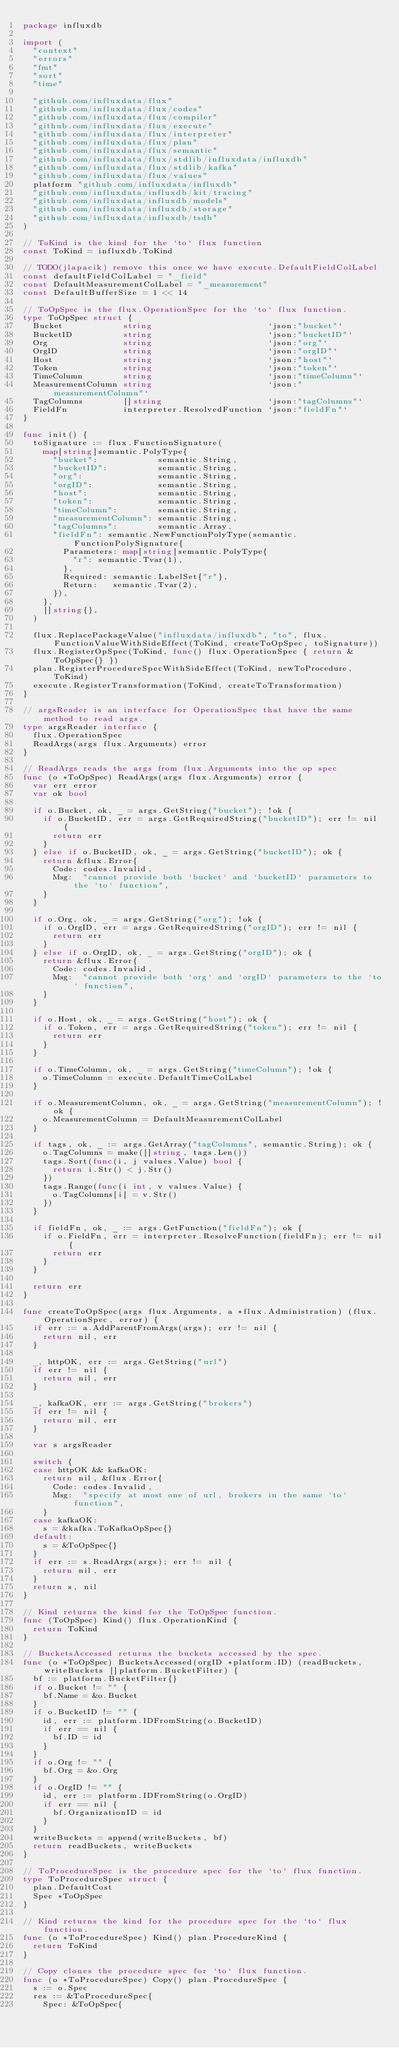<code> <loc_0><loc_0><loc_500><loc_500><_Go_>package influxdb

import (
	"context"
	"errors"
	"fmt"
	"sort"
	"time"

	"github.com/influxdata/flux"
	"github.com/influxdata/flux/codes"
	"github.com/influxdata/flux/compiler"
	"github.com/influxdata/flux/execute"
	"github.com/influxdata/flux/interpreter"
	"github.com/influxdata/flux/plan"
	"github.com/influxdata/flux/semantic"
	"github.com/influxdata/flux/stdlib/influxdata/influxdb"
	"github.com/influxdata/flux/stdlib/kafka"
	"github.com/influxdata/flux/values"
	platform "github.com/influxdata/influxdb"
	"github.com/influxdata/influxdb/kit/tracing"
	"github.com/influxdata/influxdb/models"
	"github.com/influxdata/influxdb/storage"
	"github.com/influxdata/influxdb/tsdb"
)

// ToKind is the kind for the `to` flux function
const ToKind = influxdb.ToKind

// TODO(jlapacik) remove this once we have execute.DefaultFieldColLabel
const defaultFieldColLabel = "_field"
const DefaultMeasurementColLabel = "_measurement"
const DefaultBufferSize = 1 << 14

// ToOpSpec is the flux.OperationSpec for the `to` flux function.
type ToOpSpec struct {
	Bucket            string                       `json:"bucket"`
	BucketID          string                       `json:"bucketID"`
	Org               string                       `json:"org"`
	OrgID             string                       `json:"orgID"`
	Host              string                       `json:"host"`
	Token             string                       `json:"token"`
	TimeColumn        string                       `json:"timeColumn"`
	MeasurementColumn string                       `json:"measurementColumn"`
	TagColumns        []string                     `json:"tagColumns"`
	FieldFn           interpreter.ResolvedFunction `json:"fieldFn"`
}

func init() {
	toSignature := flux.FunctionSignature(
		map[string]semantic.PolyType{
			"bucket":            semantic.String,
			"bucketID":          semantic.String,
			"org":               semantic.String,
			"orgID":             semantic.String,
			"host":              semantic.String,
			"token":             semantic.String,
			"timeColumn":        semantic.String,
			"measurementColumn": semantic.String,
			"tagColumns":        semantic.Array,
			"fieldFn": semantic.NewFunctionPolyType(semantic.FunctionPolySignature{
				Parameters: map[string]semantic.PolyType{
					"r": semantic.Tvar(1),
				},
				Required: semantic.LabelSet{"r"},
				Return:   semantic.Tvar(2),
			}),
		},
		[]string{},
	)

	flux.ReplacePackageValue("influxdata/influxdb", "to", flux.FunctionValueWithSideEffect(ToKind, createToOpSpec, toSignature))
	flux.RegisterOpSpec(ToKind, func() flux.OperationSpec { return &ToOpSpec{} })
	plan.RegisterProcedureSpecWithSideEffect(ToKind, newToProcedure, ToKind)
	execute.RegisterTransformation(ToKind, createToTransformation)
}

// argsReader is an interface for OperationSpec that have the same method to read args.
type argsReader interface {
	flux.OperationSpec
	ReadArgs(args flux.Arguments) error
}

// ReadArgs reads the args from flux.Arguments into the op spec
func (o *ToOpSpec) ReadArgs(args flux.Arguments) error {
	var err error
	var ok bool

	if o.Bucket, ok, _ = args.GetString("bucket"); !ok {
		if o.BucketID, err = args.GetRequiredString("bucketID"); err != nil {
			return err
		}
	} else if o.BucketID, ok, _ = args.GetString("bucketID"); ok {
		return &flux.Error{
			Code: codes.Invalid,
			Msg:  "cannot provide both `bucket` and `bucketID` parameters to the `to` function",
		}
	}

	if o.Org, ok, _ = args.GetString("org"); !ok {
		if o.OrgID, err = args.GetRequiredString("orgID"); err != nil {
			return err
		}
	} else if o.OrgID, ok, _ = args.GetString("orgID"); ok {
		return &flux.Error{
			Code: codes.Invalid,
			Msg:  "cannot provide both `org` and `orgID` parameters to the `to` function",
		}
	}

	if o.Host, ok, _ = args.GetString("host"); ok {
		if o.Token, err = args.GetRequiredString("token"); err != nil {
			return err
		}
	}

	if o.TimeColumn, ok, _ = args.GetString("timeColumn"); !ok {
		o.TimeColumn = execute.DefaultTimeColLabel
	}

	if o.MeasurementColumn, ok, _ = args.GetString("measurementColumn"); !ok {
		o.MeasurementColumn = DefaultMeasurementColLabel
	}

	if tags, ok, _ := args.GetArray("tagColumns", semantic.String); ok {
		o.TagColumns = make([]string, tags.Len())
		tags.Sort(func(i, j values.Value) bool {
			return i.Str() < j.Str()
		})
		tags.Range(func(i int, v values.Value) {
			o.TagColumns[i] = v.Str()
		})
	}

	if fieldFn, ok, _ := args.GetFunction("fieldFn"); ok {
		if o.FieldFn, err = interpreter.ResolveFunction(fieldFn); err != nil {
			return err
		}
	}

	return err
}

func createToOpSpec(args flux.Arguments, a *flux.Administration) (flux.OperationSpec, error) {
	if err := a.AddParentFromArgs(args); err != nil {
		return nil, err
	}

	_, httpOK, err := args.GetString("url")
	if err != nil {
		return nil, err
	}

	_, kafkaOK, err := args.GetString("brokers")
	if err != nil {
		return nil, err
	}

	var s argsReader

	switch {
	case httpOK && kafkaOK:
		return nil, &flux.Error{
			Code: codes.Invalid,
			Msg:  "specify at most one of url, brokers in the same `to` function",
		}
	case kafkaOK:
		s = &kafka.ToKafkaOpSpec{}
	default:
		s = &ToOpSpec{}
	}
	if err := s.ReadArgs(args); err != nil {
		return nil, err
	}
	return s, nil
}

// Kind returns the kind for the ToOpSpec function.
func (ToOpSpec) Kind() flux.OperationKind {
	return ToKind
}

// BucketsAccessed returns the buckets accessed by the spec.
func (o *ToOpSpec) BucketsAccessed(orgID *platform.ID) (readBuckets, writeBuckets []platform.BucketFilter) {
	bf := platform.BucketFilter{}
	if o.Bucket != "" {
		bf.Name = &o.Bucket
	}
	if o.BucketID != "" {
		id, err := platform.IDFromString(o.BucketID)
		if err == nil {
			bf.ID = id
		}
	}
	if o.Org != "" {
		bf.Org = &o.Org
	}
	if o.OrgID != "" {
		id, err := platform.IDFromString(o.OrgID)
		if err == nil {
			bf.OrganizationID = id
		}
	}
	writeBuckets = append(writeBuckets, bf)
	return readBuckets, writeBuckets
}

// ToProcedureSpec is the procedure spec for the `to` flux function.
type ToProcedureSpec struct {
	plan.DefaultCost
	Spec *ToOpSpec
}

// Kind returns the kind for the procedure spec for the `to` flux function.
func (o *ToProcedureSpec) Kind() plan.ProcedureKind {
	return ToKind
}

// Copy clones the procedure spec for `to` flux function.
func (o *ToProcedureSpec) Copy() plan.ProcedureSpec {
	s := o.Spec
	res := &ToProcedureSpec{
		Spec: &ToOpSpec{</code> 